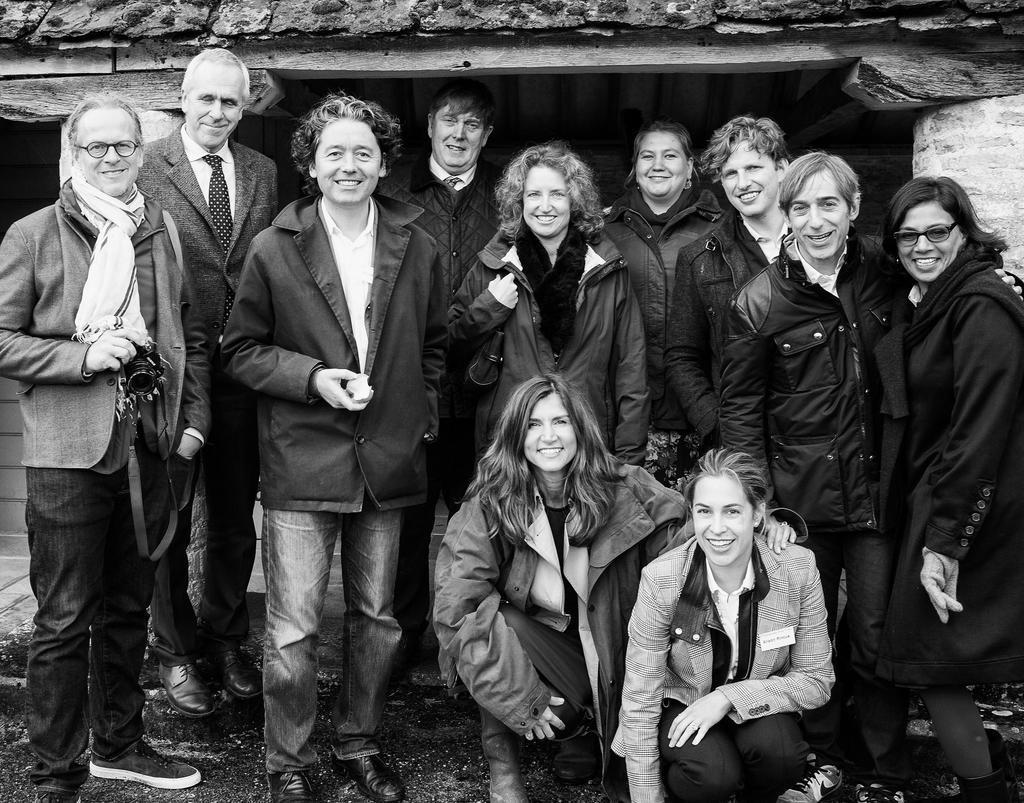In one or two sentences, can you explain what this image depicts? In this image there are group of persons, there are persons truncated towards the bottom of the image, there is a person truncated towards the left of the image, there is a person truncated towards the right of the image, there are persons holding an object, at the background of the image there is the wall truncated. 